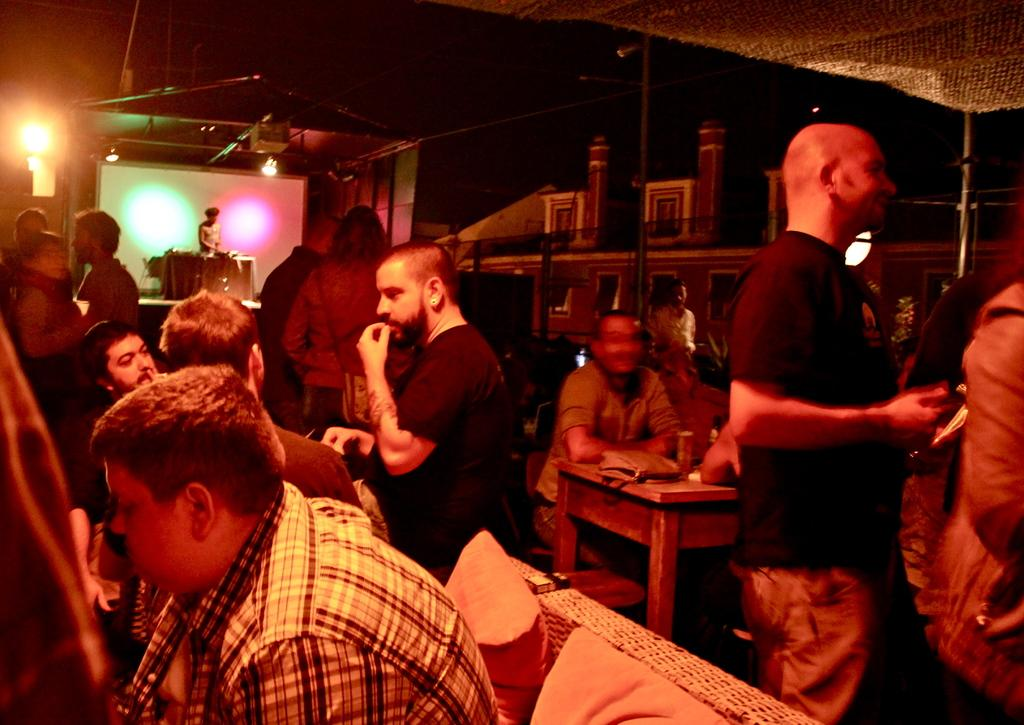How many people are in the image? There is a group of people in the image, but the exact number is not specified. What are the people in the image doing? Some people are sitting, while others are standing. What objects can be seen in the image besides the people? There are pillows and a table in the image. What can be seen in the background of the image? In the background, there is a person standing on a stage, and lights are visible. What direction is the wind blowing in the image? There is no mention of wind in the image, so it cannot be determined which direction the wind is blowing. 